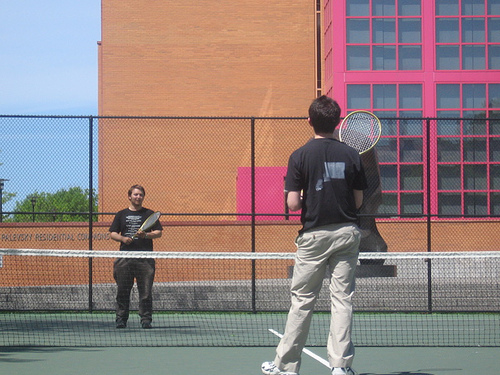Please identify all text content in this image. RESIDENTAL 